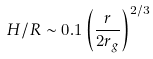<formula> <loc_0><loc_0><loc_500><loc_500>H / R \sim 0 . 1 \left ( \frac { r } { 2 r _ { g } } \right ) ^ { 2 / 3 }</formula> 